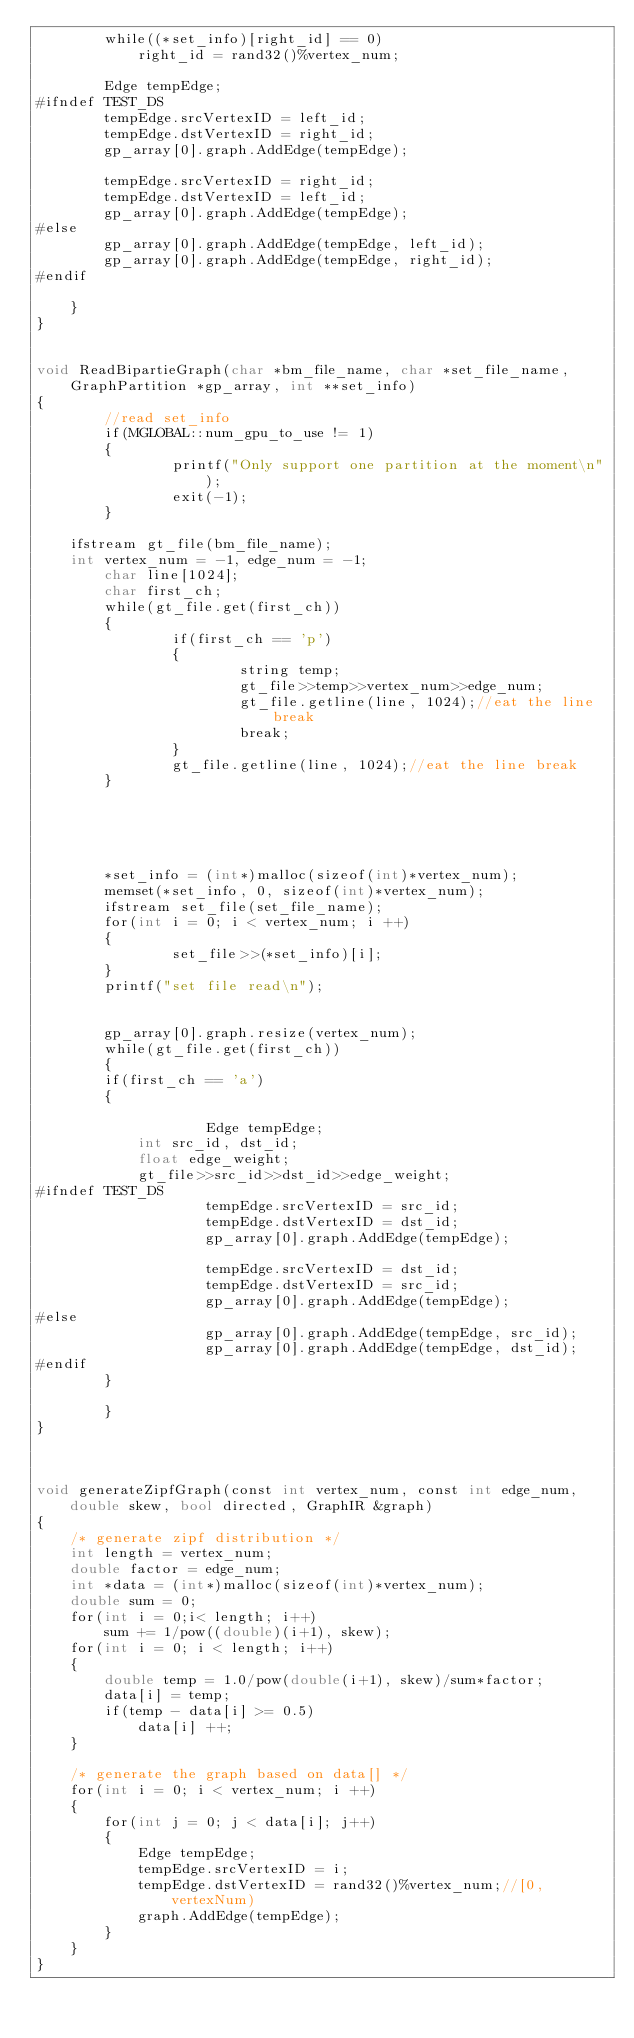Convert code to text. <code><loc_0><loc_0><loc_500><loc_500><_Cuda_>		while((*set_info)[right_id] == 0)
			right_id = rand32()%vertex_num;

		Edge tempEdge;
#ifndef TEST_DS	
		tempEdge.srcVertexID = left_id;
		tempEdge.dstVertexID = right_id;
		gp_array[0].graph.AddEdge(tempEdge);

		tempEdge.srcVertexID = right_id;
		tempEdge.dstVertexID = left_id;
		gp_array[0].graph.AddEdge(tempEdge);
#else
		gp_array[0].graph.AddEdge(tempEdge, left_id);
		gp_array[0].graph.AddEdge(tempEdge, right_id);
#endif

	}
}


void ReadBipartieGraph(char *bm_file_name, char *set_file_name, GraphPartition *gp_array, int **set_info)
{
        //read set_info
        if(MGLOBAL::num_gpu_to_use != 1)
        {
                printf("Only support one partition at the moment\n");
                exit(-1);
        }

	ifstream gt_file(bm_file_name);
	int vertex_num = -1, edge_num = -1;
        char line[1024];
        char first_ch;
        while(gt_file.get(first_ch))
        {
                if(first_ch == 'p')
                {
                        string temp;
                        gt_file>>temp>>vertex_num>>edge_num;
                        gt_file.getline(line, 1024);//eat the line break
                        break;
                }
                gt_file.getline(line, 1024);//eat the line break
        }





        *set_info = (int*)malloc(sizeof(int)*vertex_num);
        memset(*set_info, 0, sizeof(int)*vertex_num);
        ifstream set_file(set_file_name);
        for(int i = 0; i < vertex_num; i ++)
        {
                set_file>>(*set_info)[i];
        }
        printf("set file read\n");


        gp_array[0].graph.resize(vertex_num);
        while(gt_file.get(first_ch))
        {
		if(first_ch == 'a')
		{

	                Edge tempEdge;
			int src_id, dst_id;
			float edge_weight;
			gt_file>>src_id>>dst_id>>edge_weight;
#ifndef TEST_DS
	                tempEdge.srcVertexID = src_id;
	                tempEdge.dstVertexID = dst_id;
	                gp_array[0].graph.AddEdge(tempEdge);

        	        tempEdge.srcVertexID = dst_id;
       	       		tempEdge.dstVertexID = src_id;
                	gp_array[0].graph.AddEdge(tempEdge);
#else
                	gp_array[0].graph.AddEdge(tempEdge, src_id);
                	gp_array[0].graph.AddEdge(tempEdge, dst_id);
#endif
		}

        }
}



void generateZipfGraph(const int vertex_num, const int edge_num, double skew, bool directed, GraphIR &graph)
{
	/* generate zipf distribution */
	int length = vertex_num;
	double factor = edge_num;
	int *data = (int*)malloc(sizeof(int)*vertex_num);
	double sum = 0;
	for(int i = 0;i< length; i++)
		sum += 1/pow((double)(i+1), skew);
	for(int i = 0; i < length; i++)
	{
		double temp = 1.0/pow(double(i+1), skew)/sum*factor;
		data[i] = temp;
		if(temp - data[i] >= 0.5)
			data[i] ++;
	}

	/* generate the graph based on data[] */
	for(int i = 0; i < vertex_num; i ++)
	{
		for(int j = 0; j < data[i]; j++)
		{
			Edge tempEdge;
			tempEdge.srcVertexID = i;
			tempEdge.dstVertexID = rand32()%vertex_num;//[0,vertexNum)
			graph.AddEdge(tempEdge);
		}
	}
}
</code> 